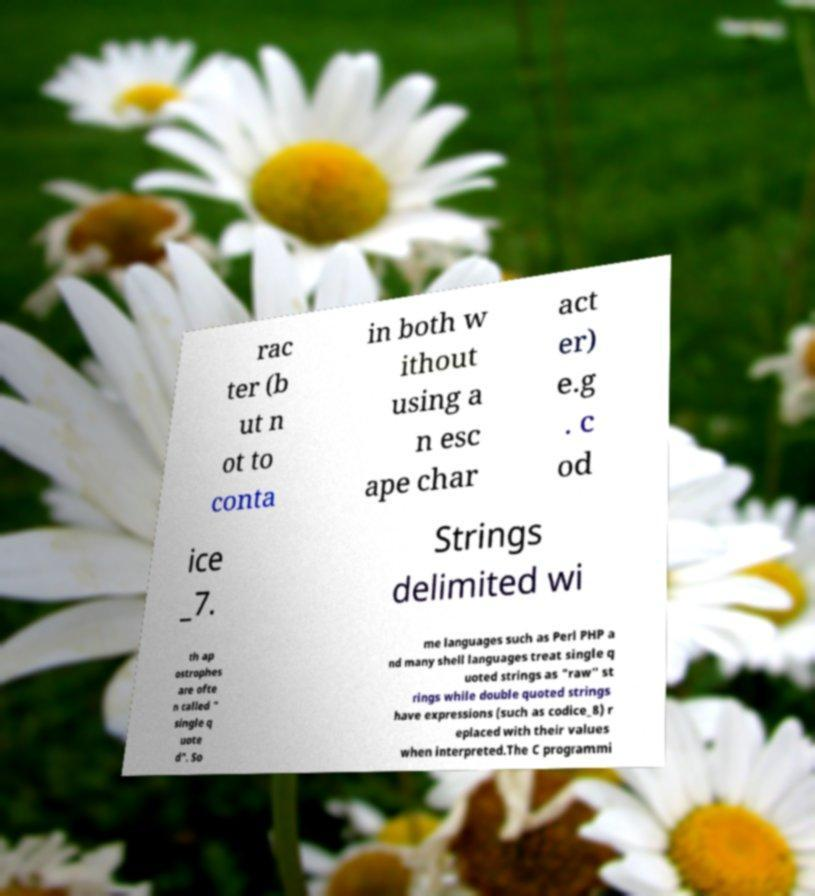There's text embedded in this image that I need extracted. Can you transcribe it verbatim? rac ter (b ut n ot to conta in both w ithout using a n esc ape char act er) e.g . c od ice _7. Strings delimited wi th ap ostrophes are ofte n called " single q uote d". So me languages such as Perl PHP a nd many shell languages treat single q uoted strings as "raw" st rings while double quoted strings have expressions (such as codice_8) r eplaced with their values when interpreted.The C programmi 